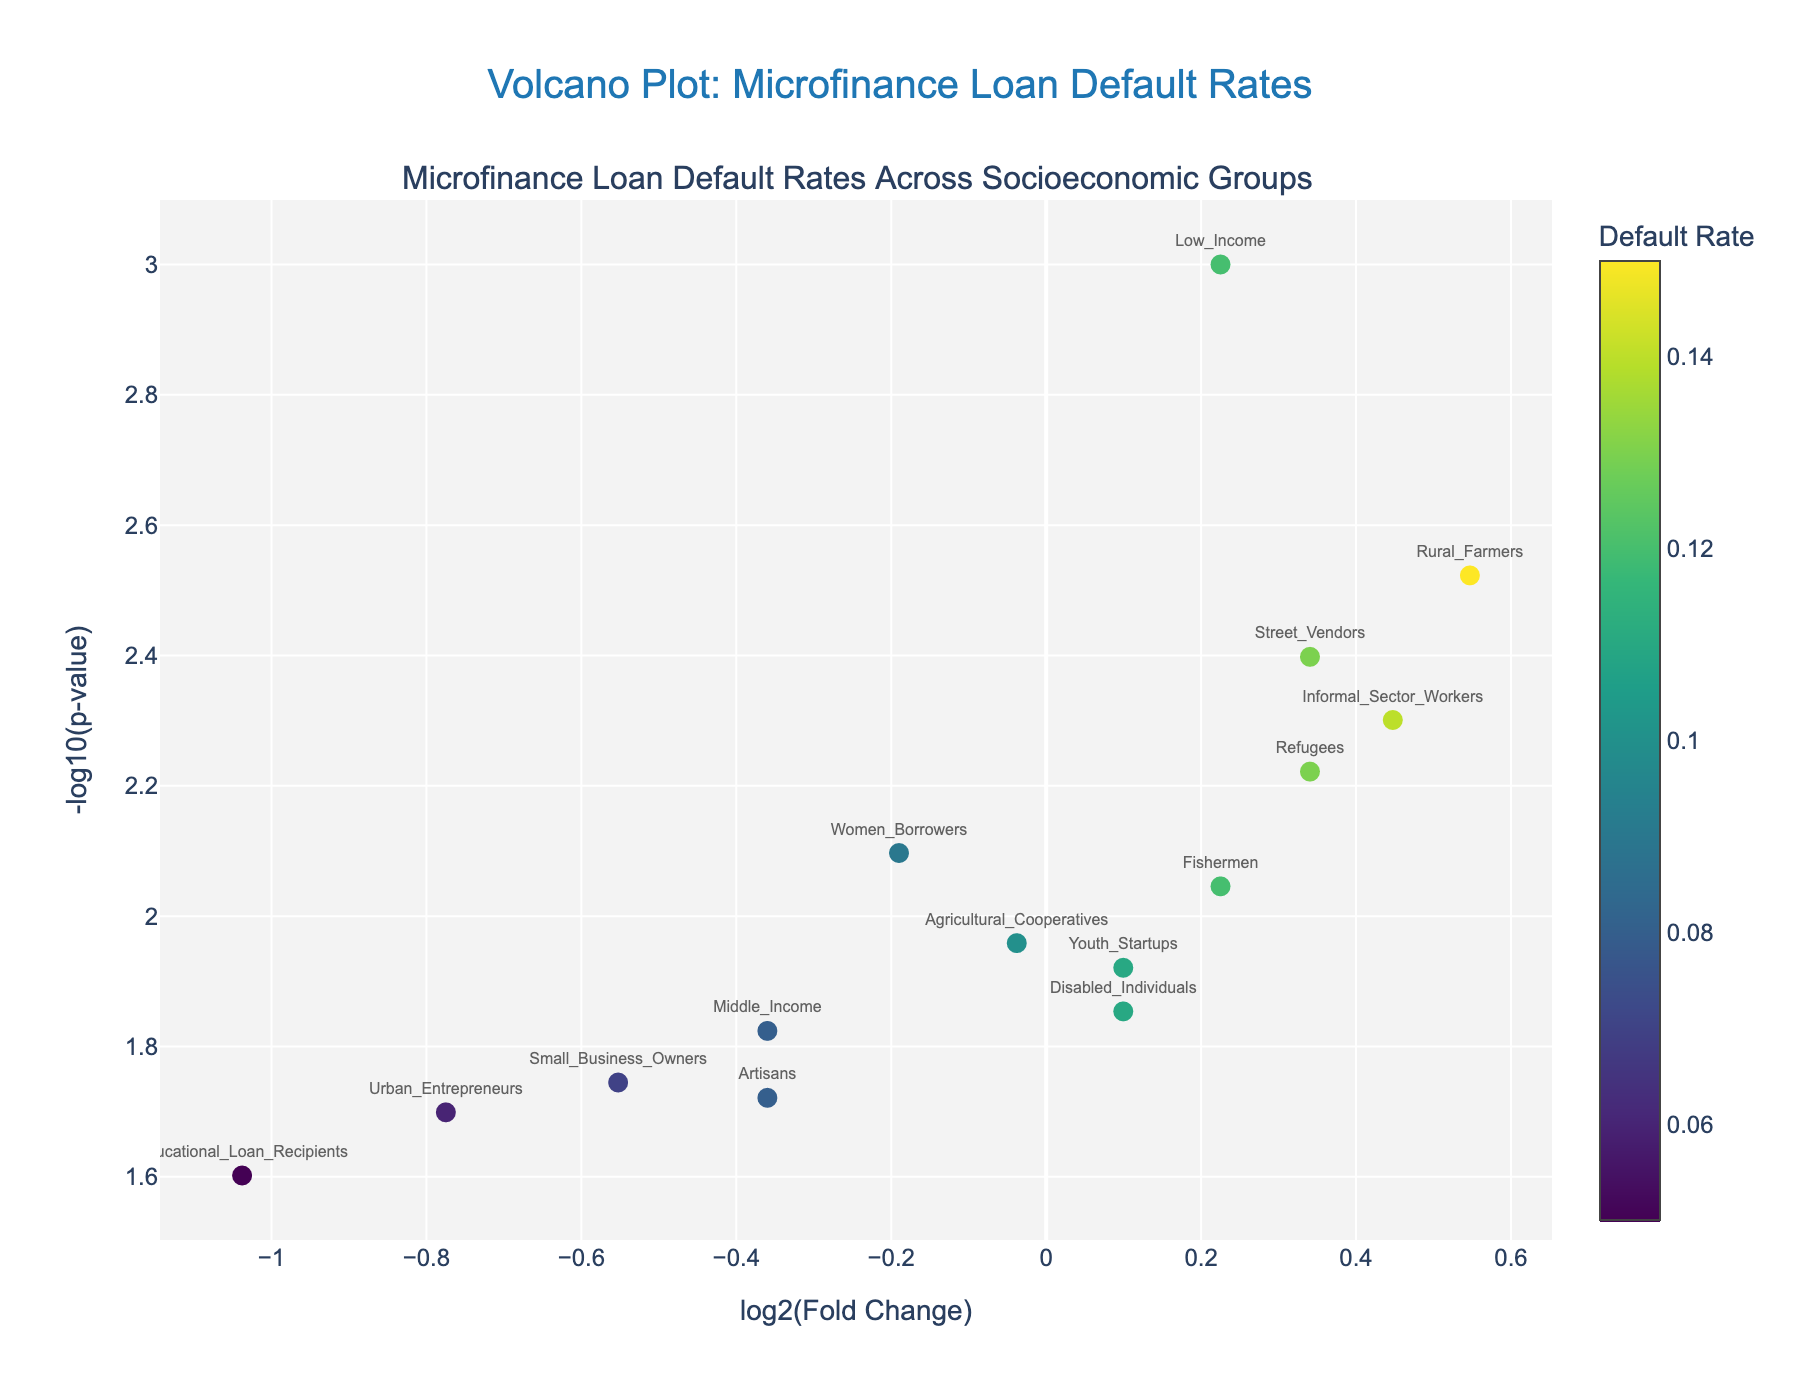Which group has the highest default rate? By examining the y-axis hover information and comparing the default rates of all groups, we can identify that "Rural Farmers" have the highest default rate of 0.15.
Answer: Rural Farmers What is the default rate for Women Borrowers? By hovering over the data point labeled "Women Borrowers," we can see the default rate for this group, which is 0.09.
Answer: 0.09 Which group has the lowest default rate? By comparing the default rates of all groups shown on the hover information, we see that Educational Loan Recipients have the lowest default rate of 0.05.
Answer: Educational Loan Recipients Which groups have a p-value below 0.01? By examining the hover information of the data points where the -log10(p-value) is greater than 2 (since -log10(0.01) = 2), we identify Low Income, Rural Farmers, Women Borrowers, Informal Sector Workers, Refugees, Street Vendors, and Fishermen.
Answer: Low Income, Rural Farmers, Women Borrowers, Informal Sector Workers, Refugees, Street Vendors, Fishermen What is the fold change in default rate for Youth Startups compared to the average default rate? The hover text and x-axis show that the fold change (log2) for Youth Startups is slightly above 0, indicating their default rate is slightly above the group's average. Specifically, since log2(0.11/0.1) ≈ 0.1375, it signifies this fold change.
Answer: 0.1375 Which two groups have nearly equal default rates but differing p-values? By comparing the hover information for default rates and noting matching rates but differing p-values, we find that Youth Startups and Disabled Individuals, both with a 0.11 default rate, have different p-values (0.012 vs. 0.014, resulting in different y-axis positions).
Answer: Youth Startups and Disabled Individuals How many groups have default rates above 0.1? Visual inspection of hover information reveals seven groups (Low Income, Rural Farmers, Youth Startups, Informal Sector Workers, Refugees, Fishermen, and Street Vendors) with default rates above 0.1.
Answer: Seven Which group has the highest statistical significance? By identifying the highest y-axis value (-log10(p-value)), the group "Low Income" with a -log10(p-value) around 3 represents the highest statistical significance (p=0.001).
Answer: Low Income Is there a correlation between default rate and p-value? By examining overall patterns, no clear correlation exists between default rate and p-value, given data points' varying positions regardless of color intensity representing default rate.
Answer: No clear correlation Which group is an outlier in terms of both low default rate and high p-value? By spotting the data point at the lowest default rate and relatively high -log10(p-value) (on the lower left), "Educational Loan Recipients" stand out.
Answer: Educational Loan Recipients 